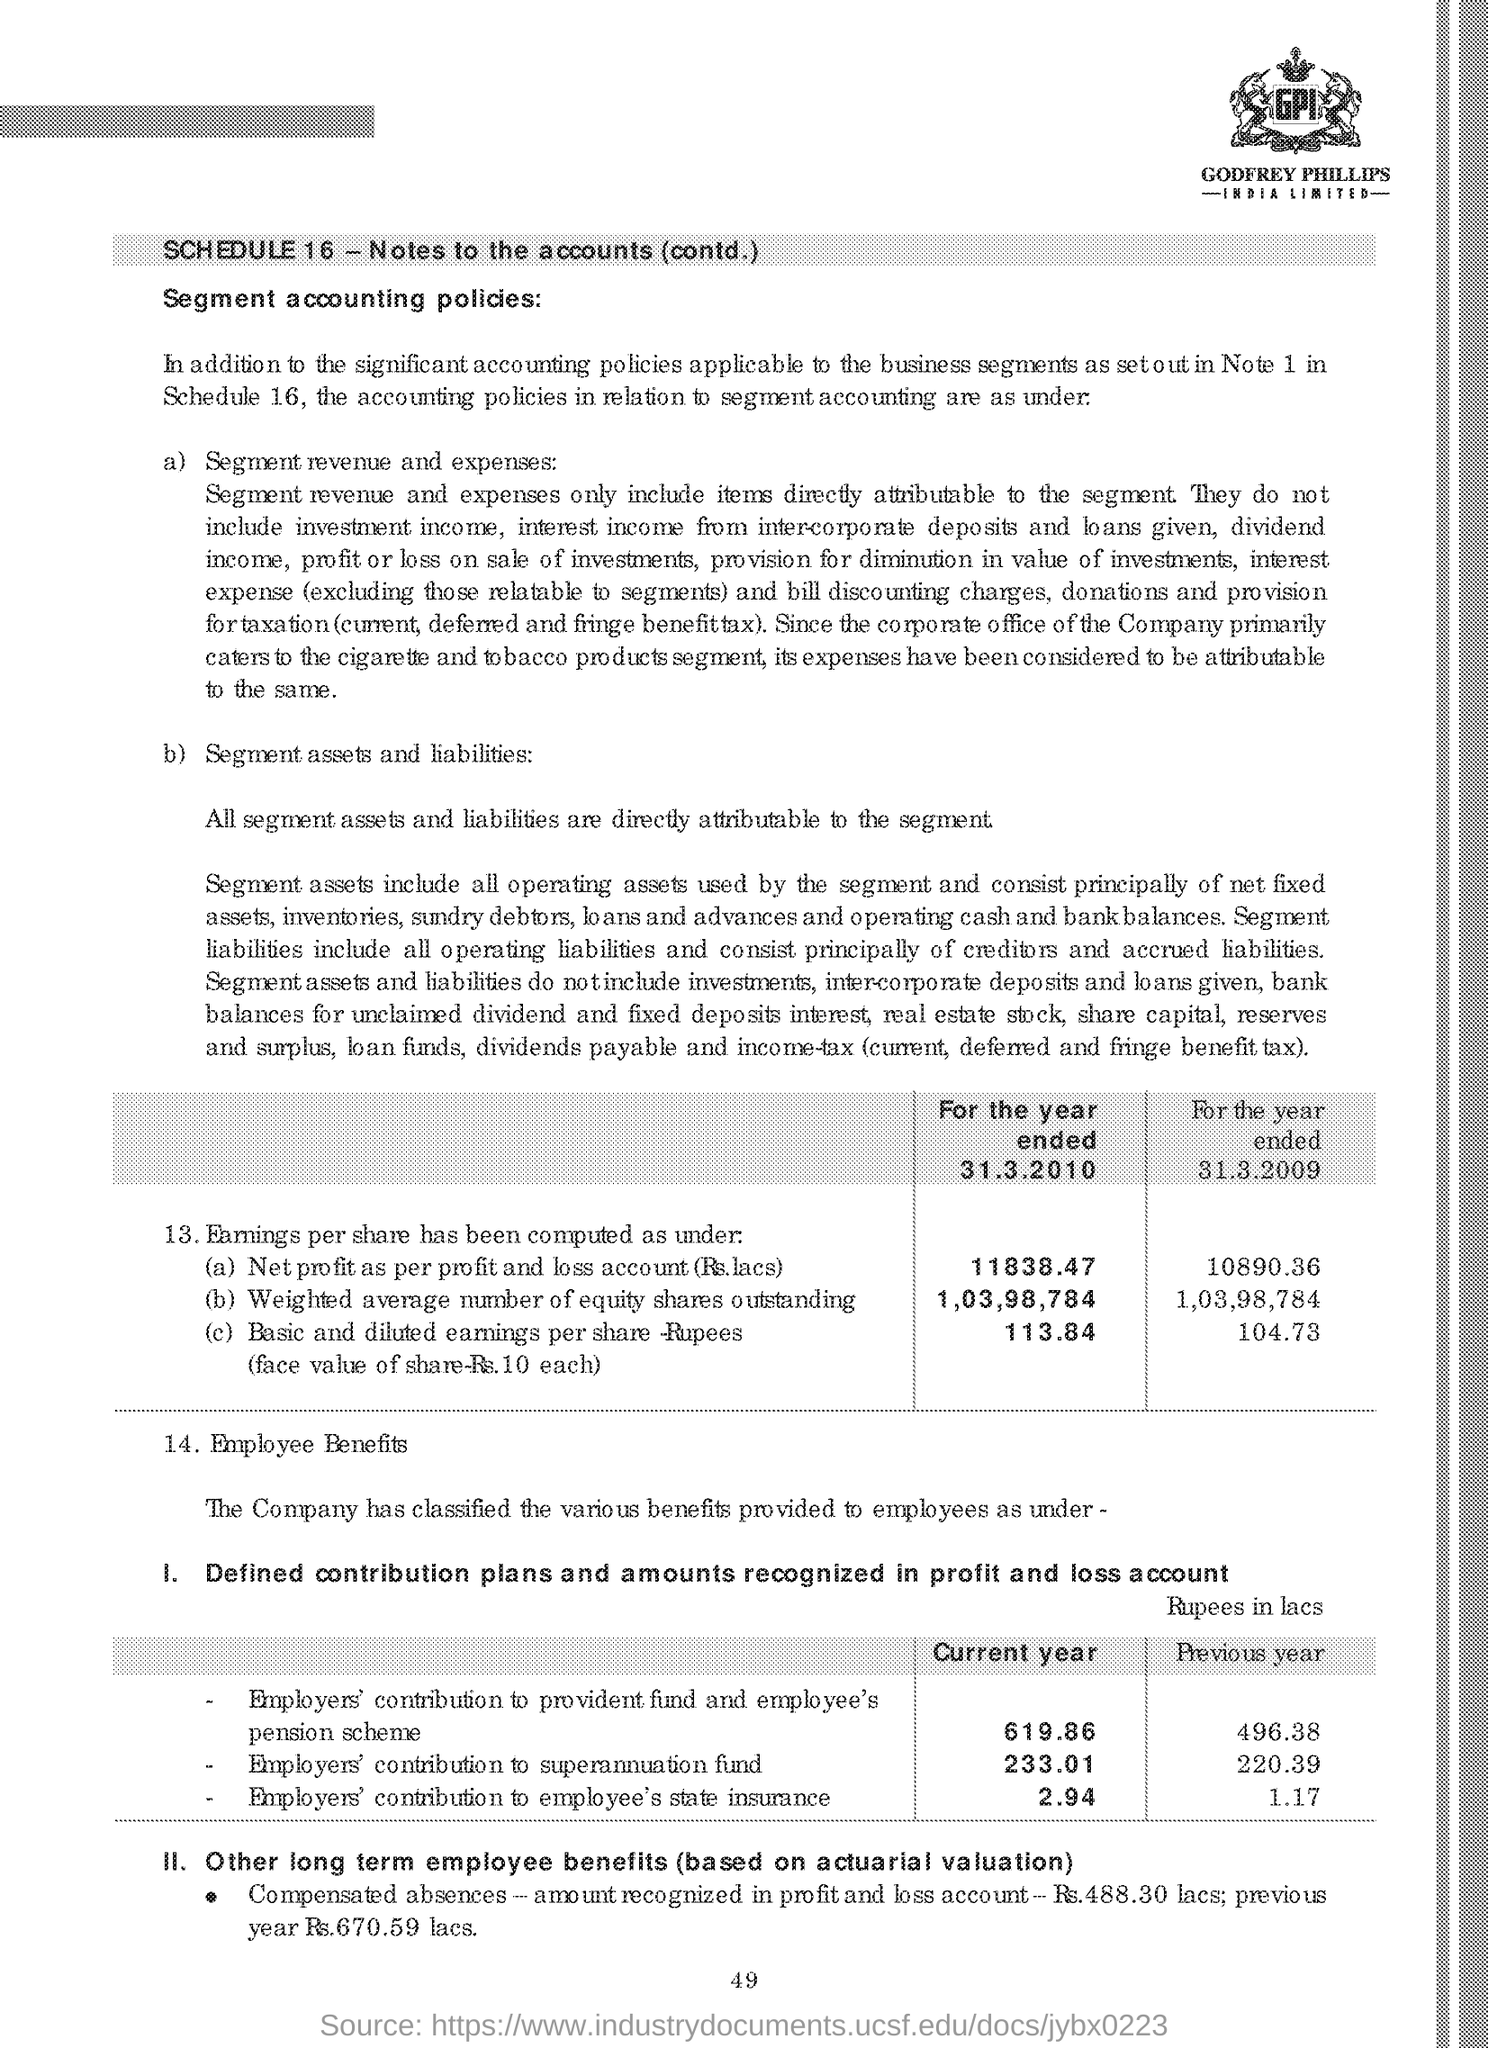What is the employers' contribution (Rupees in lacs) to superannuation fund in the current year?
Offer a very short reply. 233.01. What is the employers' contribution (Rupees in lacs) to employee's state insurance in the previous year?
Offer a very short reply. 1.17. What is the Net profit(Rs. lacs) as per the profit and loss account for the year ended 31.3.2010?
Offer a terse response. 11838.47. What is the weighted average number of equity shares outstanding for the year ended 31.03.2009?
Your answer should be compact. 1,03,98,784. What is the Employers' contribution (Rupees in lacs) to provident fund and employee's pension scheme in the current year?
Give a very brief answer. 619.86. What is the page no mentioned in this document?
Make the answer very short. 49. 